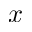<formula> <loc_0><loc_0><loc_500><loc_500>x</formula> 